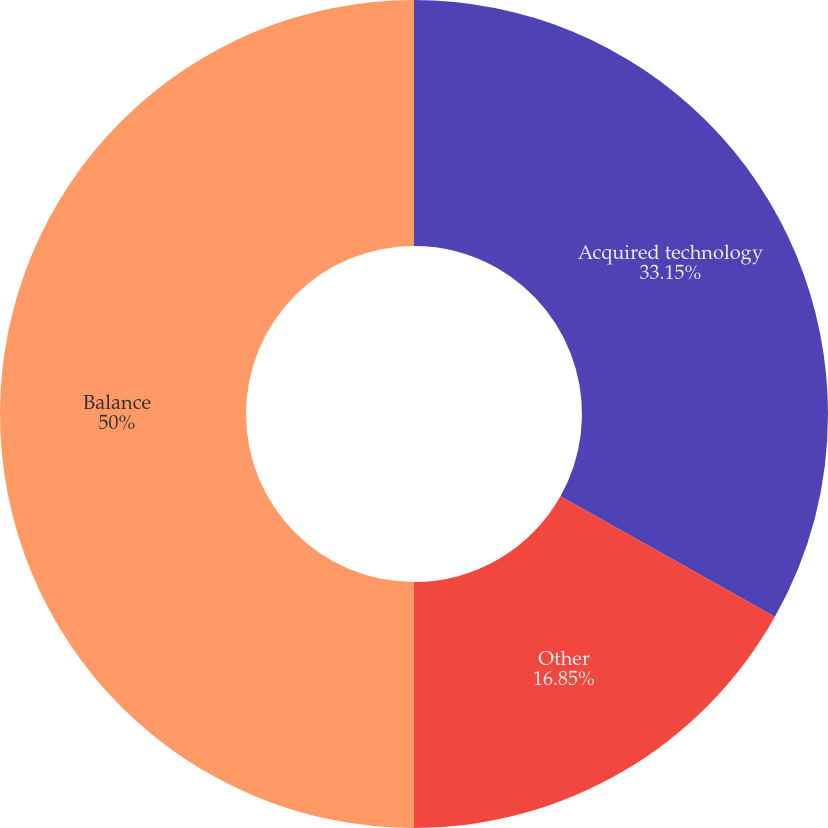<chart> <loc_0><loc_0><loc_500><loc_500><pie_chart><fcel>Acquired technology<fcel>Other<fcel>Balance<nl><fcel>33.15%<fcel>16.85%<fcel>50.0%<nl></chart> 